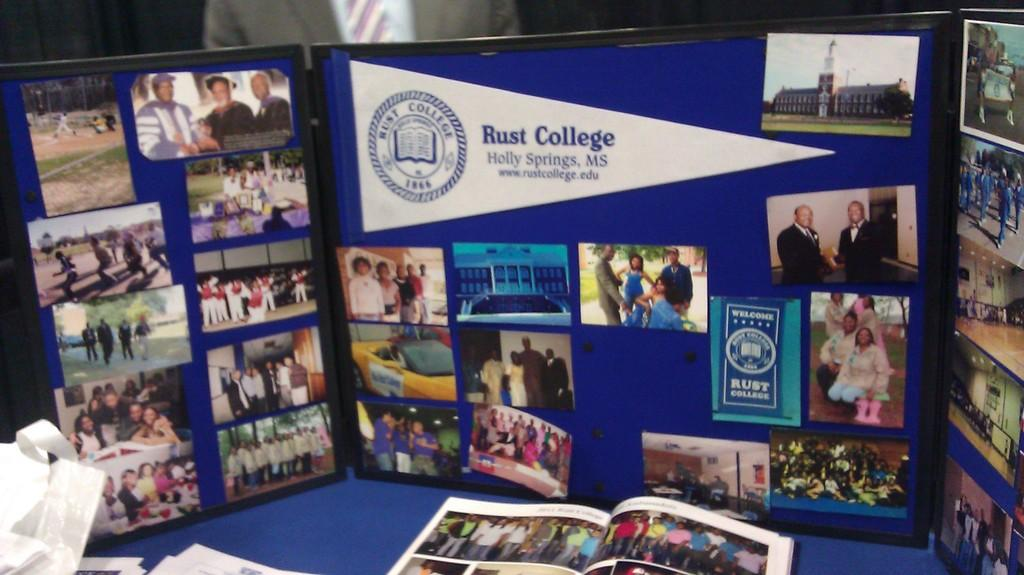Provide a one-sentence caption for the provided image. A display board about Rust College is sitting on a table. 